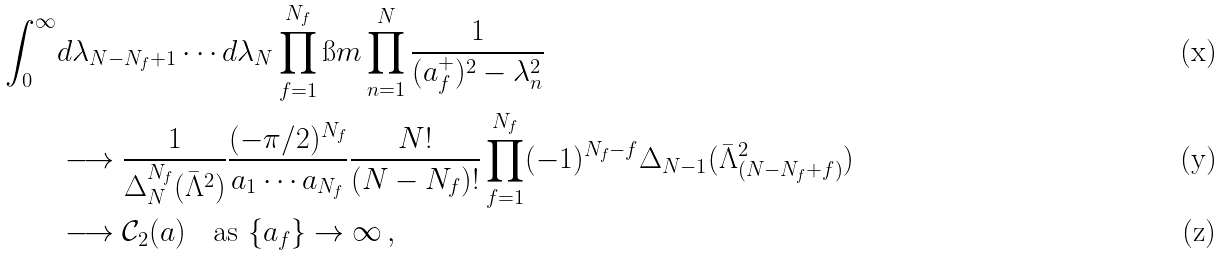<formula> <loc_0><loc_0><loc_500><loc_500>\int _ { 0 } ^ { \infty } & d \lambda _ { N - N _ { f } + 1 } \cdots d \lambda _ { N } \prod _ { f = 1 } ^ { N _ { f } } \i m \prod _ { n = 1 } ^ { N } \frac { 1 } { ( a _ { f } ^ { + } ) ^ { 2 } - \lambda _ { n } ^ { 2 } } \\ & \longrightarrow \frac { 1 } { \Delta _ { N } ^ { N _ { f } } ( \bar { \Lambda } ^ { 2 } ) } \frac { ( - \pi / 2 ) ^ { N _ { f } } } { a _ { 1 } \cdots a _ { N _ { f } } } \frac { N ! } { ( N - N _ { f } ) ! } \prod _ { f = 1 } ^ { N _ { f } } ( - 1 ) ^ { N _ { f } - f } \Delta _ { N - 1 } ( \bar { \Lambda } _ { ( N - N _ { f } + f ) } ^ { 2 } ) \\ & \longrightarrow \mathcal { C } _ { 2 } ( a ) \quad \text {as $\{a_{f}\}\to\infty$} \, ,</formula> 